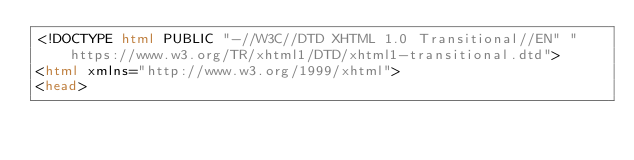Convert code to text. <code><loc_0><loc_0><loc_500><loc_500><_HTML_><!DOCTYPE html PUBLIC "-//W3C//DTD XHTML 1.0 Transitional//EN" "https://www.w3.org/TR/xhtml1/DTD/xhtml1-transitional.dtd">
<html xmlns="http://www.w3.org/1999/xhtml">
<head></code> 